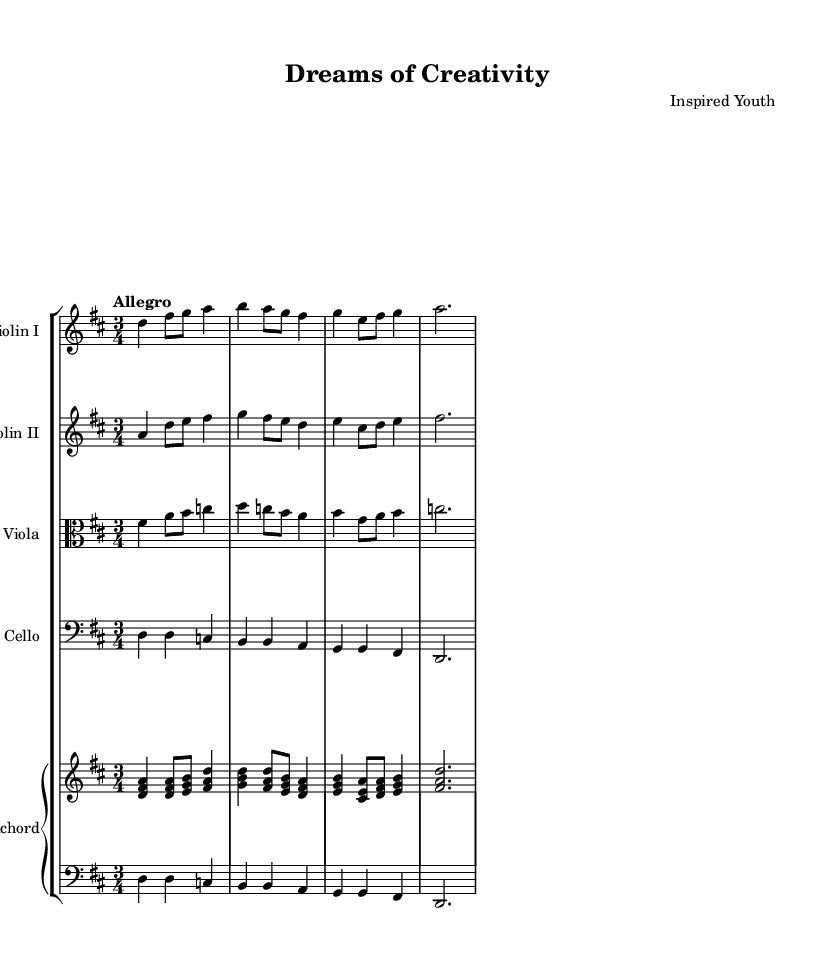What is the key signature of this music? The key signature is D major, which has two sharps (F# and C#) indicated by the key signature at the beginning of the staff.
Answer: D major What is the time signature of this music? The time signature is 3/4, shown at the beginning of the score where there are three beats per measure with a quarter note receiving one beat.
Answer: 3/4 What is the tempo marking for this piece? The tempo marking is "Allegro," which suggests a fast and lively pace, typically ranging from 120 to 168 beats per minute.
Answer: Allegro How many violin parts are present in this score? There are two violin parts shown as "Violin I" and "Violin II" in separate staves right after the header.
Answer: Two Which instrument has the clef labeled 'alto'? The instrument with the clef labeled 'alto' is the viola, as indicated when that staff is introduced in the score.
Answer: Viola What is the last note played by the harpsichord? The last note played by the harpsichord is A, which is sustained in the final measure as a whole note before the piece concludes.
Answer: A What type of music is this piece categorized as? This piece is categorized as Baroque music due to its style, instrumentation, and characteristics such as ornamentation and counterpoint found throughout the score.
Answer: Baroque 